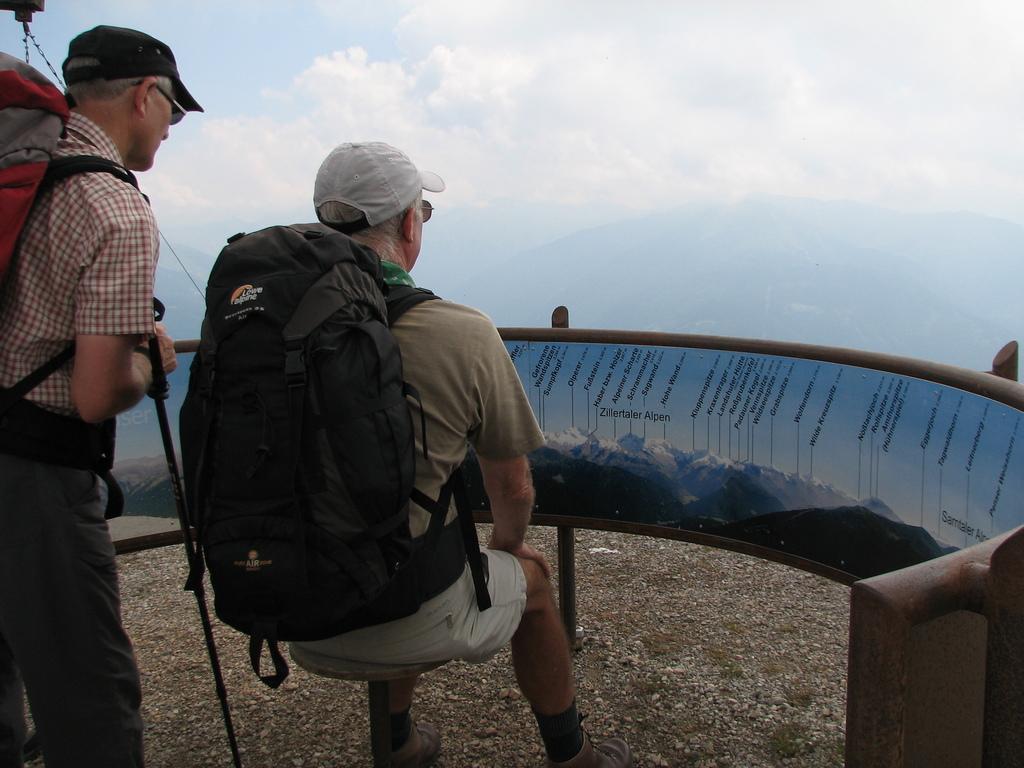How would you summarize this image in a sentence or two? In this image we can see two persons wearing backpacks, one of them is holding a walking stick, and the other guy is sitting on a stool, in front of them there is a fencing with some text on it, also we can see some mountains, and the sky. 